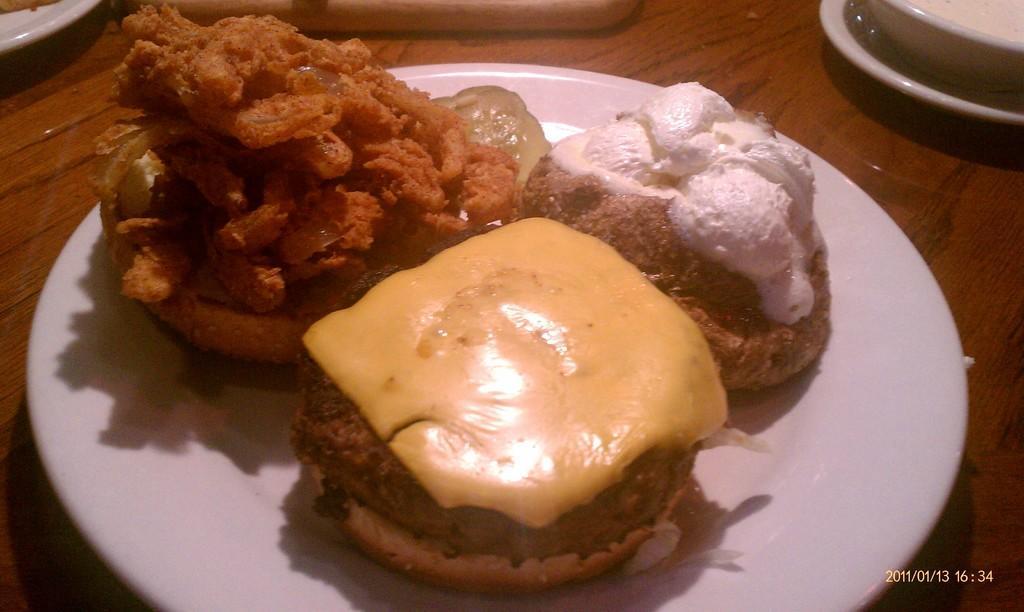How would you summarize this image in a sentence or two? In this image there is a table, on that table there is a plate in that plate there is food item, in the bottom right there is date and time. 